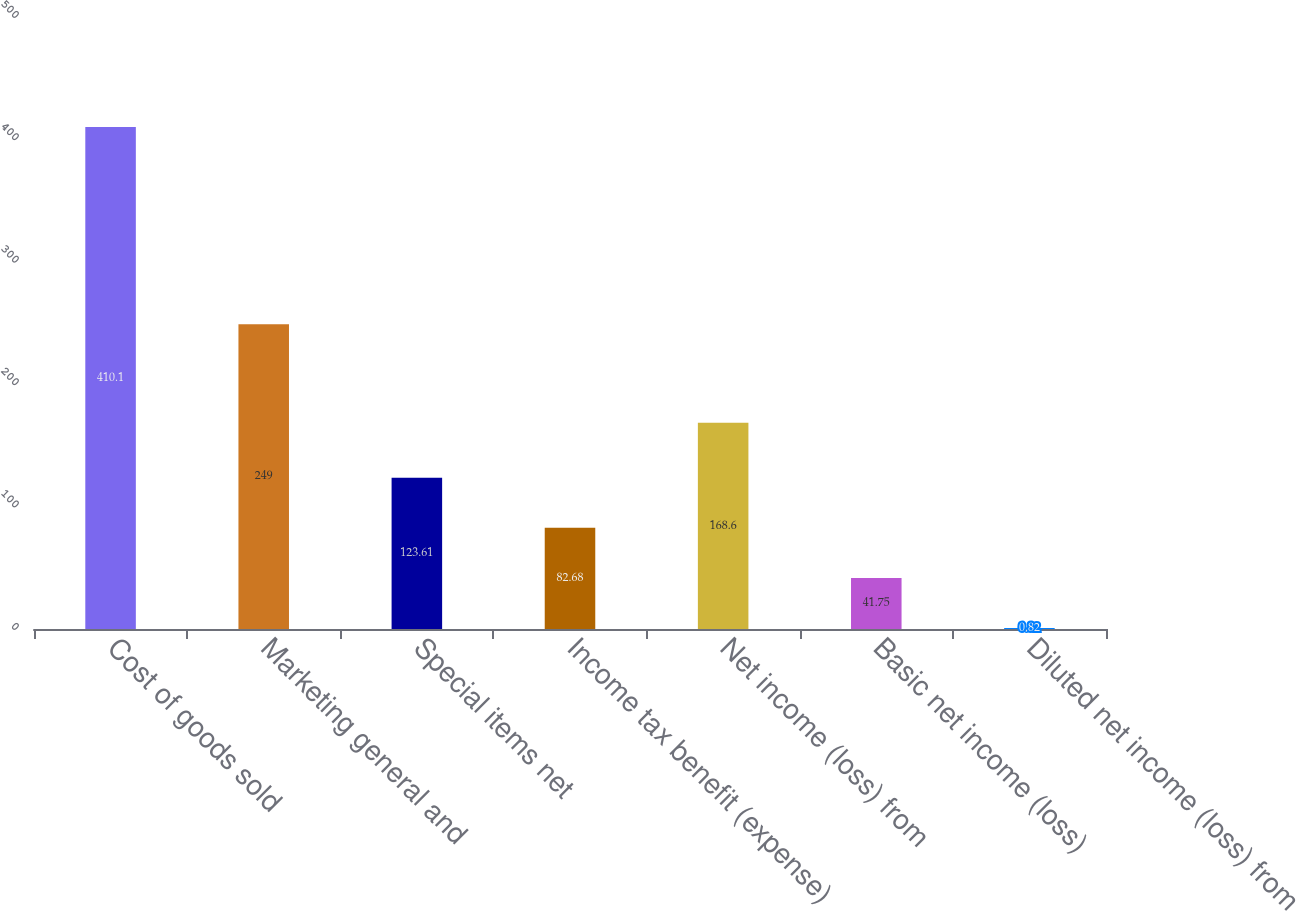Convert chart. <chart><loc_0><loc_0><loc_500><loc_500><bar_chart><fcel>Cost of goods sold<fcel>Marketing general and<fcel>Special items net<fcel>Income tax benefit (expense)<fcel>Net income (loss) from<fcel>Basic net income (loss)<fcel>Diluted net income (loss) from<nl><fcel>410.1<fcel>249<fcel>123.61<fcel>82.68<fcel>168.6<fcel>41.75<fcel>0.82<nl></chart> 